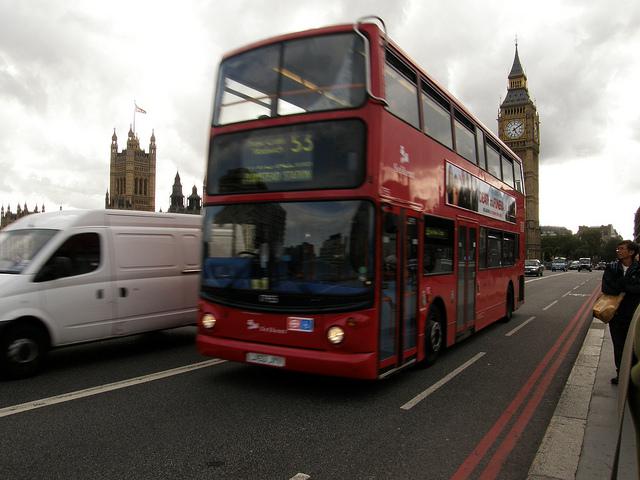How is this vehicle powered?
Quick response, please. Gas. What is the bus called?
Short answer required. Double decker. What modes of transportation are being depicted?
Answer briefly. Bus. What are the two towers supporting?
Write a very short answer. Bridge. What number bus is in the photo?
Quick response, please. 53. Is they close to a stop?
Concise answer only. No. What is the bus number?
Be succinct. 53. What number is on the bus?
Give a very brief answer. 53. What number is on the front of the bus?
Concise answer only. 53. Which bus is the smallest?
Keep it brief. Left. What kind of vehicle has pulled up right next to the bus?
Keep it brief. Van. Does the bus have its headlights on?
Be succinct. Yes. Why is the color scheme of the photo?
Keep it brief. Red. What color is the minivan?
Answer briefly. White. Is there snow on this street?
Be succinct. No. What two English words sound like the pronunciation of the black letters on the bus?
Short answer required. No black letters. What color is the bus?
Keep it brief. Red. Is the door to the bus open?
Answer briefly. No. What color is this bus?
Answer briefly. Red. Is the bus one color?
Concise answer only. Yes. Why is the bus red?
Concise answer only. Yes. What country do the flags represent?
Short answer required. England. Are the trees visible?
Be succinct. No. What bus number is this?
Write a very short answer. 55. What is the number on the bus?
Give a very brief answer. 53. Are any of the vehicles moving?
Answer briefly. Yes. How many lights are on the front of the bus?
Quick response, please. 2. 